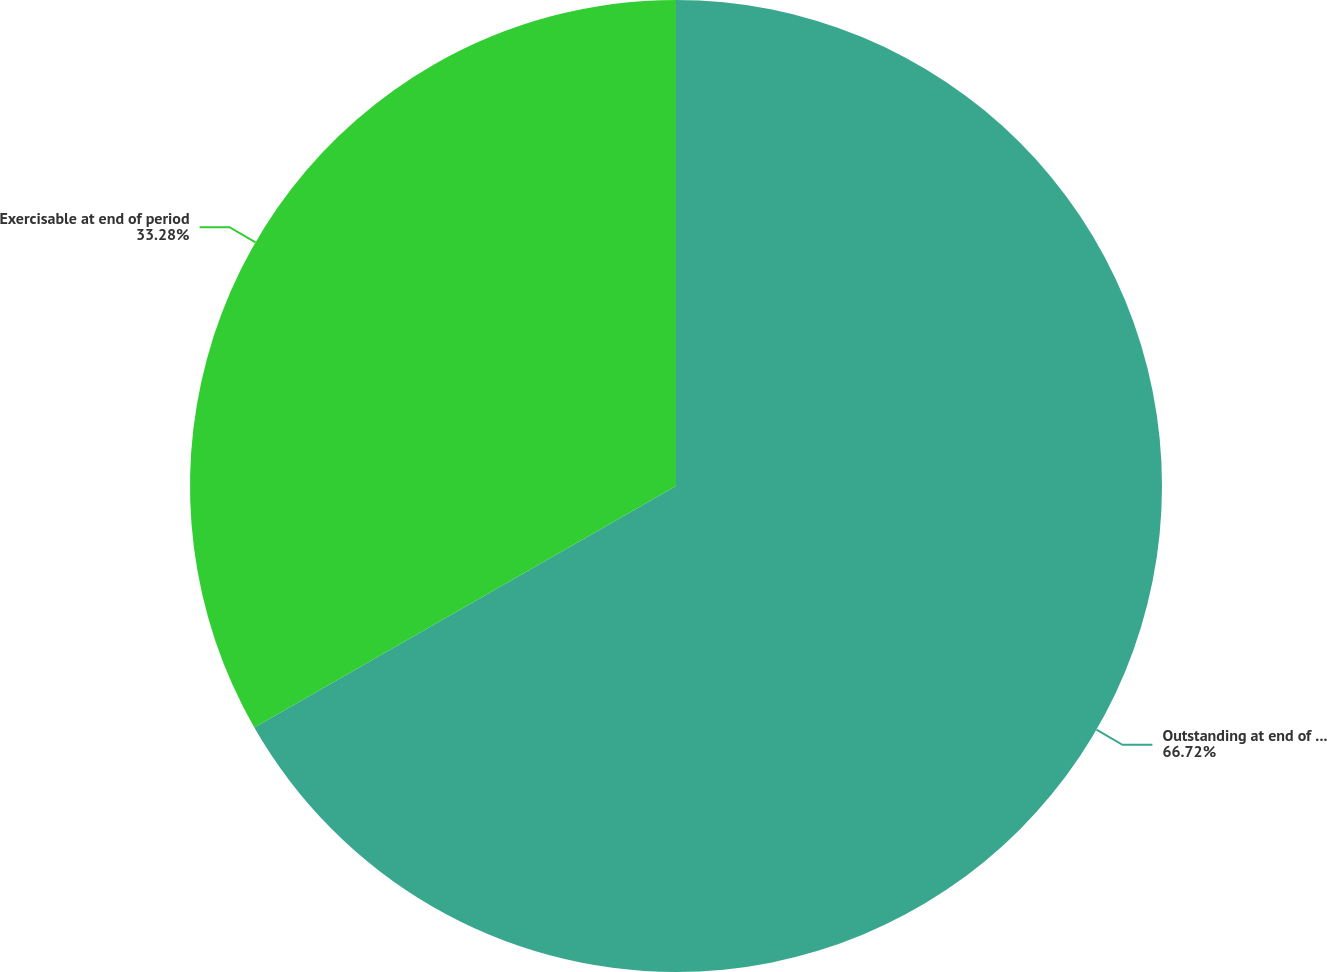Convert chart to OTSL. <chart><loc_0><loc_0><loc_500><loc_500><pie_chart><fcel>Outstanding at end of period<fcel>Exercisable at end of period<nl><fcel>66.72%<fcel>33.28%<nl></chart> 